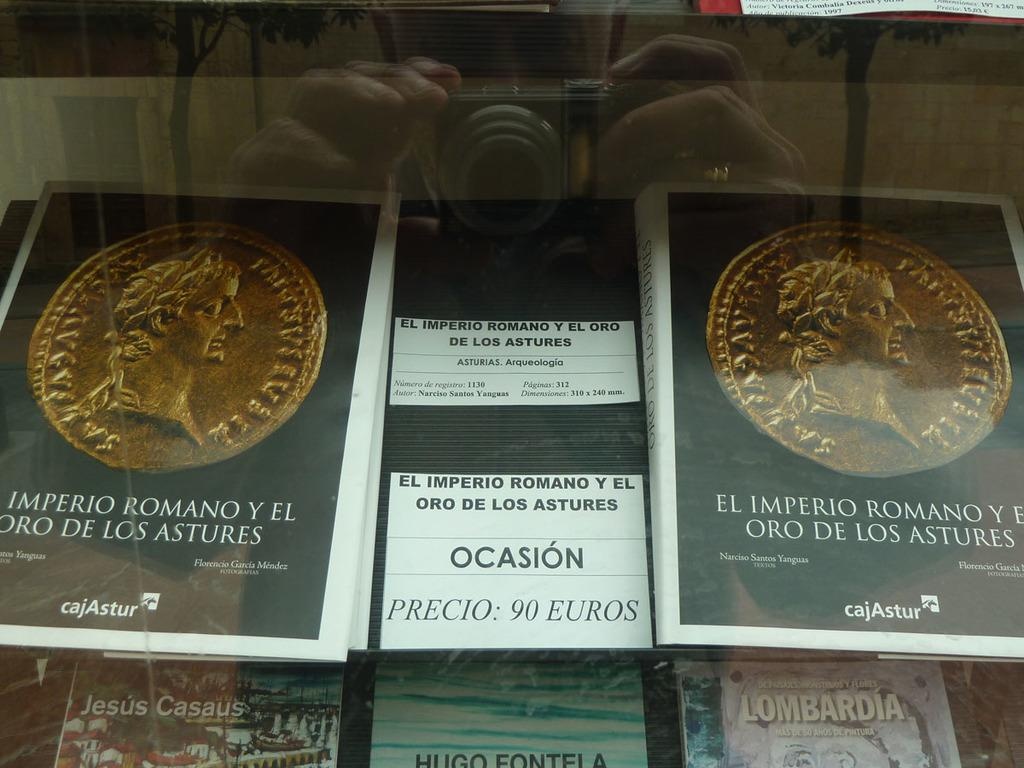<image>
Create a compact narrative representing the image presented. A bunch of rare coins from another country and selling for 90 Euros. 